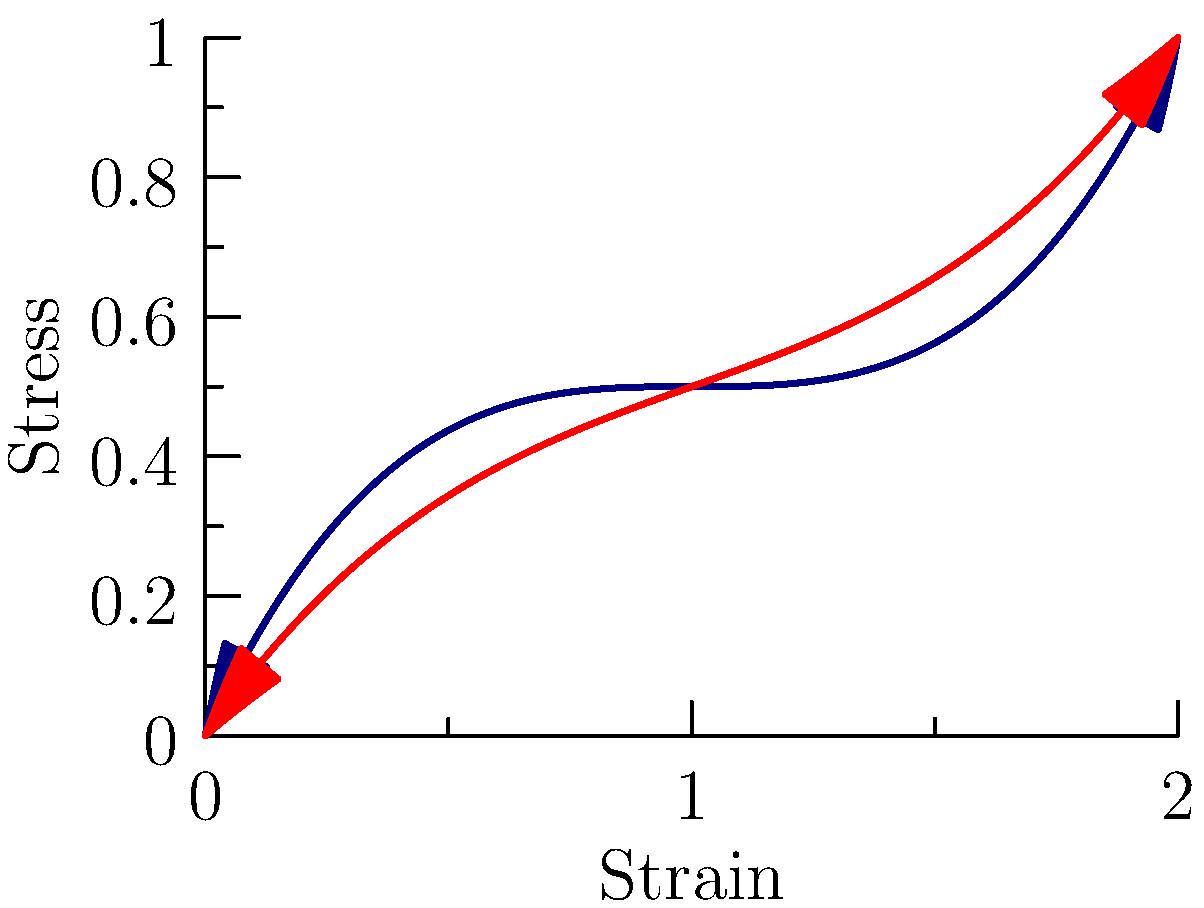Given the stress-strain curves for two complex materials (A and B) under various loading conditions, analyze the graph and determine which material exhibits higher stiffness in the elastic region. Justify your answer using the principles of material mechanics. To determine which material has higher stiffness in the elastic region, we need to follow these steps:

1. Recall that stiffness is represented by the slope of the stress-strain curve in the elastic region. The steeper the slope, the higher the stiffness.

2. Identify the elastic region for both materials:
   - The elastic region is typically the initial linear portion of the stress-strain curve.
   - For both materials, this appears to be approximately from strain 0 to 0.5.

3. Compare the slopes of the two curves in the elastic region:
   - Material A (blue curve): The slope is steeper in the initial portion.
   - Material B (red curve): The slope is less steep in the initial portion.

4. Calculate the approximate slopes:
   - For Material A: $\frac{\Delta\text{Stress}}{\Delta\text{Strain}} \approx \frac{f(0.5) - f(0)}{0.5 - 0} \approx \frac{0.6875 - 0}{0.5} \approx 1.375$
   - For Material B: $\frac{\Delta\text{Stress}}{\Delta\text{Strain}} \approx \frac{g(0.5) - g(0)}{0.5 - 0} \approx \frac{0.46875 - 0}{0.5} \approx 0.9375$

5. Compare the calculated slopes:
   The slope of Material A (1.375) is greater than the slope of Material B (0.9375).

Therefore, Material A exhibits higher stiffness in the elastic region.
Answer: Material A has higher stiffness due to steeper slope in the elastic region. 